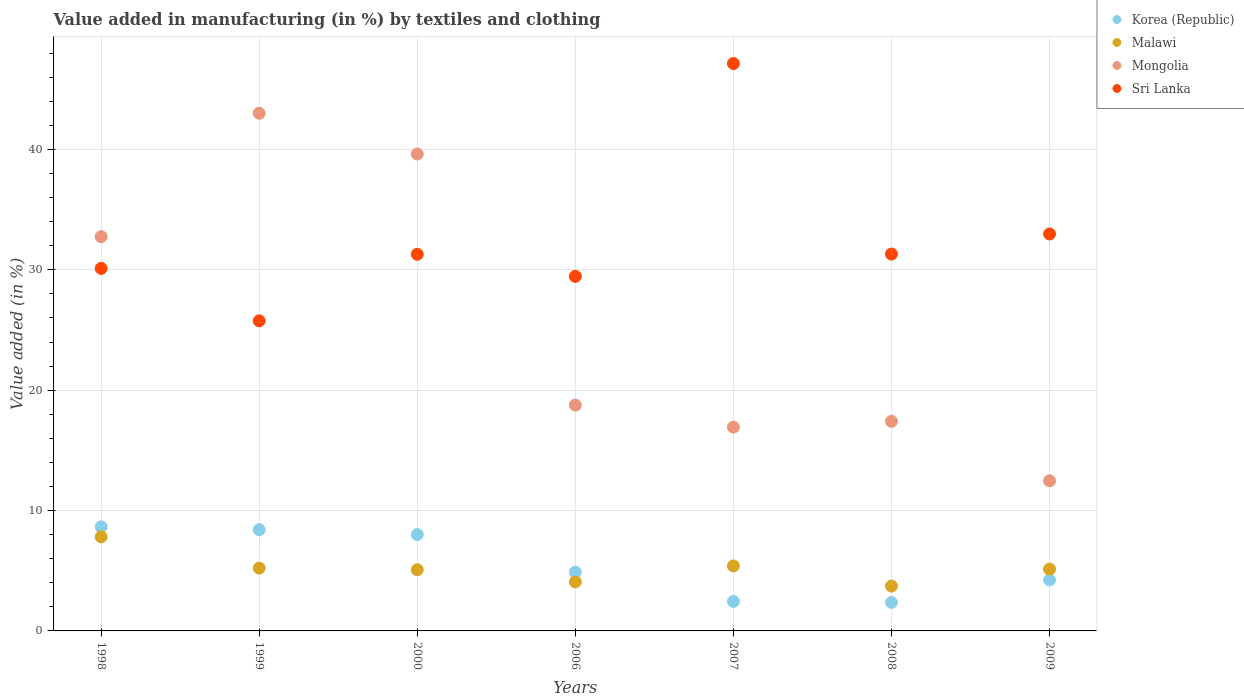Is the number of dotlines equal to the number of legend labels?
Offer a terse response. Yes. What is the percentage of value added in manufacturing by textiles and clothing in Korea (Republic) in 2009?
Ensure brevity in your answer.  4.24. Across all years, what is the maximum percentage of value added in manufacturing by textiles and clothing in Malawi?
Offer a very short reply. 7.82. Across all years, what is the minimum percentage of value added in manufacturing by textiles and clothing in Korea (Republic)?
Offer a terse response. 2.36. What is the total percentage of value added in manufacturing by textiles and clothing in Mongolia in the graph?
Make the answer very short. 180.93. What is the difference between the percentage of value added in manufacturing by textiles and clothing in Korea (Republic) in 1998 and that in 2006?
Provide a succinct answer. 3.76. What is the difference between the percentage of value added in manufacturing by textiles and clothing in Mongolia in 1999 and the percentage of value added in manufacturing by textiles and clothing in Malawi in 2008?
Give a very brief answer. 39.28. What is the average percentage of value added in manufacturing by textiles and clothing in Mongolia per year?
Offer a very short reply. 25.85. In the year 1998, what is the difference between the percentage of value added in manufacturing by textiles and clothing in Korea (Republic) and percentage of value added in manufacturing by textiles and clothing in Mongolia?
Make the answer very short. -24.1. What is the ratio of the percentage of value added in manufacturing by textiles and clothing in Malawi in 2000 to that in 2007?
Provide a short and direct response. 0.94. Is the percentage of value added in manufacturing by textiles and clothing in Korea (Republic) in 1998 less than that in 2008?
Offer a terse response. No. Is the difference between the percentage of value added in manufacturing by textiles and clothing in Korea (Republic) in 1999 and 2009 greater than the difference between the percentage of value added in manufacturing by textiles and clothing in Mongolia in 1999 and 2009?
Keep it short and to the point. No. What is the difference between the highest and the second highest percentage of value added in manufacturing by textiles and clothing in Sri Lanka?
Ensure brevity in your answer.  14.16. What is the difference between the highest and the lowest percentage of value added in manufacturing by textiles and clothing in Mongolia?
Your answer should be very brief. 30.53. Is the percentage of value added in manufacturing by textiles and clothing in Malawi strictly less than the percentage of value added in manufacturing by textiles and clothing in Sri Lanka over the years?
Make the answer very short. Yes. What is the difference between two consecutive major ticks on the Y-axis?
Provide a succinct answer. 10. Does the graph contain any zero values?
Keep it short and to the point. No. Does the graph contain grids?
Provide a short and direct response. Yes. What is the title of the graph?
Give a very brief answer. Value added in manufacturing (in %) by textiles and clothing. Does "Mauritius" appear as one of the legend labels in the graph?
Offer a very short reply. No. What is the label or title of the X-axis?
Ensure brevity in your answer.  Years. What is the label or title of the Y-axis?
Ensure brevity in your answer.  Value added (in %). What is the Value added (in %) in Korea (Republic) in 1998?
Your answer should be compact. 8.65. What is the Value added (in %) of Malawi in 1998?
Make the answer very short. 7.82. What is the Value added (in %) in Mongolia in 1998?
Keep it short and to the point. 32.75. What is the Value added (in %) in Sri Lanka in 1998?
Offer a terse response. 30.11. What is the Value added (in %) of Korea (Republic) in 1999?
Give a very brief answer. 8.41. What is the Value added (in %) of Malawi in 1999?
Offer a very short reply. 5.22. What is the Value added (in %) of Mongolia in 1999?
Make the answer very short. 43.01. What is the Value added (in %) of Sri Lanka in 1999?
Your answer should be compact. 25.76. What is the Value added (in %) in Korea (Republic) in 2000?
Give a very brief answer. 8. What is the Value added (in %) in Malawi in 2000?
Provide a succinct answer. 5.08. What is the Value added (in %) of Mongolia in 2000?
Your answer should be compact. 39.61. What is the Value added (in %) of Sri Lanka in 2000?
Ensure brevity in your answer.  31.29. What is the Value added (in %) of Korea (Republic) in 2006?
Keep it short and to the point. 4.89. What is the Value added (in %) of Malawi in 2006?
Give a very brief answer. 4.07. What is the Value added (in %) in Mongolia in 2006?
Provide a succinct answer. 18.76. What is the Value added (in %) of Sri Lanka in 2006?
Provide a short and direct response. 29.45. What is the Value added (in %) in Korea (Republic) in 2007?
Give a very brief answer. 2.45. What is the Value added (in %) in Malawi in 2007?
Offer a terse response. 5.4. What is the Value added (in %) in Mongolia in 2007?
Your answer should be very brief. 16.93. What is the Value added (in %) of Sri Lanka in 2007?
Provide a short and direct response. 47.13. What is the Value added (in %) in Korea (Republic) in 2008?
Give a very brief answer. 2.36. What is the Value added (in %) of Malawi in 2008?
Provide a succinct answer. 3.73. What is the Value added (in %) in Mongolia in 2008?
Keep it short and to the point. 17.41. What is the Value added (in %) in Sri Lanka in 2008?
Provide a succinct answer. 31.31. What is the Value added (in %) of Korea (Republic) in 2009?
Offer a very short reply. 4.24. What is the Value added (in %) of Malawi in 2009?
Make the answer very short. 5.14. What is the Value added (in %) in Mongolia in 2009?
Make the answer very short. 12.47. What is the Value added (in %) of Sri Lanka in 2009?
Your response must be concise. 32.98. Across all years, what is the maximum Value added (in %) in Korea (Republic)?
Give a very brief answer. 8.65. Across all years, what is the maximum Value added (in %) in Malawi?
Provide a short and direct response. 7.82. Across all years, what is the maximum Value added (in %) of Mongolia?
Offer a terse response. 43.01. Across all years, what is the maximum Value added (in %) of Sri Lanka?
Offer a terse response. 47.13. Across all years, what is the minimum Value added (in %) of Korea (Republic)?
Provide a short and direct response. 2.36. Across all years, what is the minimum Value added (in %) of Malawi?
Your response must be concise. 3.73. Across all years, what is the minimum Value added (in %) of Mongolia?
Provide a short and direct response. 12.47. Across all years, what is the minimum Value added (in %) in Sri Lanka?
Provide a short and direct response. 25.76. What is the total Value added (in %) of Korea (Republic) in the graph?
Provide a succinct answer. 39. What is the total Value added (in %) in Malawi in the graph?
Offer a very short reply. 36.46. What is the total Value added (in %) in Mongolia in the graph?
Keep it short and to the point. 180.93. What is the total Value added (in %) of Sri Lanka in the graph?
Keep it short and to the point. 228.03. What is the difference between the Value added (in %) of Korea (Republic) in 1998 and that in 1999?
Make the answer very short. 0.24. What is the difference between the Value added (in %) in Malawi in 1998 and that in 1999?
Your response must be concise. 2.6. What is the difference between the Value added (in %) of Mongolia in 1998 and that in 1999?
Offer a terse response. -10.26. What is the difference between the Value added (in %) of Sri Lanka in 1998 and that in 1999?
Your answer should be compact. 4.36. What is the difference between the Value added (in %) of Korea (Republic) in 1998 and that in 2000?
Provide a short and direct response. 0.64. What is the difference between the Value added (in %) of Malawi in 1998 and that in 2000?
Your response must be concise. 2.74. What is the difference between the Value added (in %) of Mongolia in 1998 and that in 2000?
Provide a succinct answer. -6.87. What is the difference between the Value added (in %) in Sri Lanka in 1998 and that in 2000?
Give a very brief answer. -1.18. What is the difference between the Value added (in %) in Korea (Republic) in 1998 and that in 2006?
Offer a terse response. 3.76. What is the difference between the Value added (in %) in Malawi in 1998 and that in 2006?
Make the answer very short. 3.74. What is the difference between the Value added (in %) in Mongolia in 1998 and that in 2006?
Offer a very short reply. 13.99. What is the difference between the Value added (in %) in Sri Lanka in 1998 and that in 2006?
Your response must be concise. 0.66. What is the difference between the Value added (in %) in Korea (Republic) in 1998 and that in 2007?
Give a very brief answer. 6.2. What is the difference between the Value added (in %) in Malawi in 1998 and that in 2007?
Offer a very short reply. 2.42. What is the difference between the Value added (in %) of Mongolia in 1998 and that in 2007?
Make the answer very short. 15.82. What is the difference between the Value added (in %) in Sri Lanka in 1998 and that in 2007?
Your answer should be very brief. -17.02. What is the difference between the Value added (in %) in Korea (Republic) in 1998 and that in 2008?
Your answer should be compact. 6.28. What is the difference between the Value added (in %) of Malawi in 1998 and that in 2008?
Keep it short and to the point. 4.09. What is the difference between the Value added (in %) of Mongolia in 1998 and that in 2008?
Provide a short and direct response. 15.34. What is the difference between the Value added (in %) in Sri Lanka in 1998 and that in 2008?
Your response must be concise. -1.19. What is the difference between the Value added (in %) of Korea (Republic) in 1998 and that in 2009?
Provide a short and direct response. 4.41. What is the difference between the Value added (in %) in Malawi in 1998 and that in 2009?
Provide a short and direct response. 2.68. What is the difference between the Value added (in %) in Mongolia in 1998 and that in 2009?
Ensure brevity in your answer.  20.28. What is the difference between the Value added (in %) in Sri Lanka in 1998 and that in 2009?
Your answer should be compact. -2.86. What is the difference between the Value added (in %) of Korea (Republic) in 1999 and that in 2000?
Your answer should be very brief. 0.41. What is the difference between the Value added (in %) in Malawi in 1999 and that in 2000?
Provide a short and direct response. 0.14. What is the difference between the Value added (in %) in Mongolia in 1999 and that in 2000?
Provide a succinct answer. 3.39. What is the difference between the Value added (in %) of Sri Lanka in 1999 and that in 2000?
Offer a terse response. -5.53. What is the difference between the Value added (in %) of Korea (Republic) in 1999 and that in 2006?
Provide a succinct answer. 3.52. What is the difference between the Value added (in %) in Malawi in 1999 and that in 2006?
Your answer should be compact. 1.14. What is the difference between the Value added (in %) of Mongolia in 1999 and that in 2006?
Make the answer very short. 24.25. What is the difference between the Value added (in %) of Sri Lanka in 1999 and that in 2006?
Make the answer very short. -3.7. What is the difference between the Value added (in %) in Korea (Republic) in 1999 and that in 2007?
Ensure brevity in your answer.  5.96. What is the difference between the Value added (in %) in Malawi in 1999 and that in 2007?
Provide a succinct answer. -0.18. What is the difference between the Value added (in %) in Mongolia in 1999 and that in 2007?
Provide a succinct answer. 26.08. What is the difference between the Value added (in %) in Sri Lanka in 1999 and that in 2007?
Make the answer very short. -21.38. What is the difference between the Value added (in %) of Korea (Republic) in 1999 and that in 2008?
Make the answer very short. 6.05. What is the difference between the Value added (in %) in Malawi in 1999 and that in 2008?
Make the answer very short. 1.49. What is the difference between the Value added (in %) of Mongolia in 1999 and that in 2008?
Make the answer very short. 25.6. What is the difference between the Value added (in %) of Sri Lanka in 1999 and that in 2008?
Keep it short and to the point. -5.55. What is the difference between the Value added (in %) of Korea (Republic) in 1999 and that in 2009?
Your answer should be very brief. 4.17. What is the difference between the Value added (in %) of Malawi in 1999 and that in 2009?
Provide a succinct answer. 0.08. What is the difference between the Value added (in %) of Mongolia in 1999 and that in 2009?
Your answer should be compact. 30.53. What is the difference between the Value added (in %) in Sri Lanka in 1999 and that in 2009?
Ensure brevity in your answer.  -7.22. What is the difference between the Value added (in %) in Korea (Republic) in 2000 and that in 2006?
Ensure brevity in your answer.  3.11. What is the difference between the Value added (in %) of Malawi in 2000 and that in 2006?
Your response must be concise. 1.01. What is the difference between the Value added (in %) in Mongolia in 2000 and that in 2006?
Ensure brevity in your answer.  20.86. What is the difference between the Value added (in %) of Sri Lanka in 2000 and that in 2006?
Offer a very short reply. 1.84. What is the difference between the Value added (in %) in Korea (Republic) in 2000 and that in 2007?
Provide a short and direct response. 5.55. What is the difference between the Value added (in %) in Malawi in 2000 and that in 2007?
Give a very brief answer. -0.32. What is the difference between the Value added (in %) of Mongolia in 2000 and that in 2007?
Offer a terse response. 22.69. What is the difference between the Value added (in %) of Sri Lanka in 2000 and that in 2007?
Provide a short and direct response. -15.85. What is the difference between the Value added (in %) of Korea (Republic) in 2000 and that in 2008?
Keep it short and to the point. 5.64. What is the difference between the Value added (in %) in Malawi in 2000 and that in 2008?
Offer a very short reply. 1.35. What is the difference between the Value added (in %) in Mongolia in 2000 and that in 2008?
Your answer should be compact. 22.2. What is the difference between the Value added (in %) in Sri Lanka in 2000 and that in 2008?
Your answer should be very brief. -0.02. What is the difference between the Value added (in %) of Korea (Republic) in 2000 and that in 2009?
Offer a terse response. 3.76. What is the difference between the Value added (in %) of Malawi in 2000 and that in 2009?
Ensure brevity in your answer.  -0.06. What is the difference between the Value added (in %) of Mongolia in 2000 and that in 2009?
Your answer should be compact. 27.14. What is the difference between the Value added (in %) of Sri Lanka in 2000 and that in 2009?
Give a very brief answer. -1.69. What is the difference between the Value added (in %) of Korea (Republic) in 2006 and that in 2007?
Keep it short and to the point. 2.44. What is the difference between the Value added (in %) of Malawi in 2006 and that in 2007?
Your answer should be compact. -1.33. What is the difference between the Value added (in %) of Mongolia in 2006 and that in 2007?
Provide a short and direct response. 1.83. What is the difference between the Value added (in %) of Sri Lanka in 2006 and that in 2007?
Keep it short and to the point. -17.68. What is the difference between the Value added (in %) in Korea (Republic) in 2006 and that in 2008?
Your answer should be very brief. 2.53. What is the difference between the Value added (in %) in Malawi in 2006 and that in 2008?
Ensure brevity in your answer.  0.34. What is the difference between the Value added (in %) in Mongolia in 2006 and that in 2008?
Your response must be concise. 1.35. What is the difference between the Value added (in %) in Sri Lanka in 2006 and that in 2008?
Provide a succinct answer. -1.85. What is the difference between the Value added (in %) of Korea (Republic) in 2006 and that in 2009?
Give a very brief answer. 0.65. What is the difference between the Value added (in %) of Malawi in 2006 and that in 2009?
Your response must be concise. -1.07. What is the difference between the Value added (in %) in Mongolia in 2006 and that in 2009?
Provide a short and direct response. 6.29. What is the difference between the Value added (in %) in Sri Lanka in 2006 and that in 2009?
Provide a short and direct response. -3.52. What is the difference between the Value added (in %) of Korea (Republic) in 2007 and that in 2008?
Ensure brevity in your answer.  0.09. What is the difference between the Value added (in %) in Malawi in 2007 and that in 2008?
Keep it short and to the point. 1.67. What is the difference between the Value added (in %) in Mongolia in 2007 and that in 2008?
Your answer should be compact. -0.48. What is the difference between the Value added (in %) of Sri Lanka in 2007 and that in 2008?
Keep it short and to the point. 15.83. What is the difference between the Value added (in %) in Korea (Republic) in 2007 and that in 2009?
Offer a very short reply. -1.79. What is the difference between the Value added (in %) of Malawi in 2007 and that in 2009?
Your response must be concise. 0.26. What is the difference between the Value added (in %) of Mongolia in 2007 and that in 2009?
Your answer should be very brief. 4.46. What is the difference between the Value added (in %) in Sri Lanka in 2007 and that in 2009?
Give a very brief answer. 14.16. What is the difference between the Value added (in %) of Korea (Republic) in 2008 and that in 2009?
Your answer should be compact. -1.88. What is the difference between the Value added (in %) of Malawi in 2008 and that in 2009?
Your answer should be compact. -1.41. What is the difference between the Value added (in %) of Mongolia in 2008 and that in 2009?
Your answer should be compact. 4.94. What is the difference between the Value added (in %) in Sri Lanka in 2008 and that in 2009?
Provide a succinct answer. -1.67. What is the difference between the Value added (in %) of Korea (Republic) in 1998 and the Value added (in %) of Malawi in 1999?
Your answer should be compact. 3.43. What is the difference between the Value added (in %) of Korea (Republic) in 1998 and the Value added (in %) of Mongolia in 1999?
Your response must be concise. -34.36. What is the difference between the Value added (in %) of Korea (Republic) in 1998 and the Value added (in %) of Sri Lanka in 1999?
Your answer should be very brief. -17.11. What is the difference between the Value added (in %) of Malawi in 1998 and the Value added (in %) of Mongolia in 1999?
Your answer should be very brief. -35.19. What is the difference between the Value added (in %) in Malawi in 1998 and the Value added (in %) in Sri Lanka in 1999?
Make the answer very short. -17.94. What is the difference between the Value added (in %) in Mongolia in 1998 and the Value added (in %) in Sri Lanka in 1999?
Give a very brief answer. 6.99. What is the difference between the Value added (in %) of Korea (Republic) in 1998 and the Value added (in %) of Malawi in 2000?
Offer a terse response. 3.57. What is the difference between the Value added (in %) of Korea (Republic) in 1998 and the Value added (in %) of Mongolia in 2000?
Provide a succinct answer. -30.97. What is the difference between the Value added (in %) in Korea (Republic) in 1998 and the Value added (in %) in Sri Lanka in 2000?
Your answer should be compact. -22.64. What is the difference between the Value added (in %) in Malawi in 1998 and the Value added (in %) in Mongolia in 2000?
Keep it short and to the point. -31.8. What is the difference between the Value added (in %) of Malawi in 1998 and the Value added (in %) of Sri Lanka in 2000?
Make the answer very short. -23.47. What is the difference between the Value added (in %) of Mongolia in 1998 and the Value added (in %) of Sri Lanka in 2000?
Your response must be concise. 1.46. What is the difference between the Value added (in %) in Korea (Republic) in 1998 and the Value added (in %) in Malawi in 2006?
Provide a succinct answer. 4.57. What is the difference between the Value added (in %) in Korea (Republic) in 1998 and the Value added (in %) in Mongolia in 2006?
Your answer should be very brief. -10.11. What is the difference between the Value added (in %) of Korea (Republic) in 1998 and the Value added (in %) of Sri Lanka in 2006?
Your response must be concise. -20.81. What is the difference between the Value added (in %) in Malawi in 1998 and the Value added (in %) in Mongolia in 2006?
Offer a very short reply. -10.94. What is the difference between the Value added (in %) of Malawi in 1998 and the Value added (in %) of Sri Lanka in 2006?
Your response must be concise. -21.64. What is the difference between the Value added (in %) of Mongolia in 1998 and the Value added (in %) of Sri Lanka in 2006?
Provide a succinct answer. 3.29. What is the difference between the Value added (in %) of Korea (Republic) in 1998 and the Value added (in %) of Malawi in 2007?
Offer a very short reply. 3.25. What is the difference between the Value added (in %) of Korea (Republic) in 1998 and the Value added (in %) of Mongolia in 2007?
Your answer should be very brief. -8.28. What is the difference between the Value added (in %) in Korea (Republic) in 1998 and the Value added (in %) in Sri Lanka in 2007?
Provide a succinct answer. -38.49. What is the difference between the Value added (in %) in Malawi in 1998 and the Value added (in %) in Mongolia in 2007?
Provide a short and direct response. -9.11. What is the difference between the Value added (in %) of Malawi in 1998 and the Value added (in %) of Sri Lanka in 2007?
Provide a succinct answer. -39.32. What is the difference between the Value added (in %) in Mongolia in 1998 and the Value added (in %) in Sri Lanka in 2007?
Provide a succinct answer. -14.39. What is the difference between the Value added (in %) of Korea (Republic) in 1998 and the Value added (in %) of Malawi in 2008?
Provide a short and direct response. 4.92. What is the difference between the Value added (in %) of Korea (Republic) in 1998 and the Value added (in %) of Mongolia in 2008?
Give a very brief answer. -8.76. What is the difference between the Value added (in %) in Korea (Republic) in 1998 and the Value added (in %) in Sri Lanka in 2008?
Your answer should be compact. -22.66. What is the difference between the Value added (in %) of Malawi in 1998 and the Value added (in %) of Mongolia in 2008?
Offer a terse response. -9.59. What is the difference between the Value added (in %) of Malawi in 1998 and the Value added (in %) of Sri Lanka in 2008?
Offer a terse response. -23.49. What is the difference between the Value added (in %) in Mongolia in 1998 and the Value added (in %) in Sri Lanka in 2008?
Offer a terse response. 1.44. What is the difference between the Value added (in %) of Korea (Republic) in 1998 and the Value added (in %) of Malawi in 2009?
Provide a short and direct response. 3.51. What is the difference between the Value added (in %) in Korea (Republic) in 1998 and the Value added (in %) in Mongolia in 2009?
Provide a short and direct response. -3.82. What is the difference between the Value added (in %) in Korea (Republic) in 1998 and the Value added (in %) in Sri Lanka in 2009?
Give a very brief answer. -24.33. What is the difference between the Value added (in %) in Malawi in 1998 and the Value added (in %) in Mongolia in 2009?
Provide a succinct answer. -4.65. What is the difference between the Value added (in %) in Malawi in 1998 and the Value added (in %) in Sri Lanka in 2009?
Provide a succinct answer. -25.16. What is the difference between the Value added (in %) in Mongolia in 1998 and the Value added (in %) in Sri Lanka in 2009?
Your answer should be compact. -0.23. What is the difference between the Value added (in %) of Korea (Republic) in 1999 and the Value added (in %) of Malawi in 2000?
Make the answer very short. 3.33. What is the difference between the Value added (in %) in Korea (Republic) in 1999 and the Value added (in %) in Mongolia in 2000?
Ensure brevity in your answer.  -31.2. What is the difference between the Value added (in %) of Korea (Republic) in 1999 and the Value added (in %) of Sri Lanka in 2000?
Offer a terse response. -22.88. What is the difference between the Value added (in %) in Malawi in 1999 and the Value added (in %) in Mongolia in 2000?
Ensure brevity in your answer.  -34.4. What is the difference between the Value added (in %) in Malawi in 1999 and the Value added (in %) in Sri Lanka in 2000?
Your response must be concise. -26.07. What is the difference between the Value added (in %) in Mongolia in 1999 and the Value added (in %) in Sri Lanka in 2000?
Keep it short and to the point. 11.72. What is the difference between the Value added (in %) in Korea (Republic) in 1999 and the Value added (in %) in Malawi in 2006?
Keep it short and to the point. 4.34. What is the difference between the Value added (in %) in Korea (Republic) in 1999 and the Value added (in %) in Mongolia in 2006?
Your answer should be very brief. -10.35. What is the difference between the Value added (in %) in Korea (Republic) in 1999 and the Value added (in %) in Sri Lanka in 2006?
Provide a short and direct response. -21.04. What is the difference between the Value added (in %) in Malawi in 1999 and the Value added (in %) in Mongolia in 2006?
Keep it short and to the point. -13.54. What is the difference between the Value added (in %) in Malawi in 1999 and the Value added (in %) in Sri Lanka in 2006?
Offer a terse response. -24.24. What is the difference between the Value added (in %) of Mongolia in 1999 and the Value added (in %) of Sri Lanka in 2006?
Make the answer very short. 13.55. What is the difference between the Value added (in %) of Korea (Republic) in 1999 and the Value added (in %) of Malawi in 2007?
Offer a terse response. 3.01. What is the difference between the Value added (in %) in Korea (Republic) in 1999 and the Value added (in %) in Mongolia in 2007?
Offer a terse response. -8.52. What is the difference between the Value added (in %) of Korea (Republic) in 1999 and the Value added (in %) of Sri Lanka in 2007?
Give a very brief answer. -38.73. What is the difference between the Value added (in %) of Malawi in 1999 and the Value added (in %) of Mongolia in 2007?
Provide a succinct answer. -11.71. What is the difference between the Value added (in %) of Malawi in 1999 and the Value added (in %) of Sri Lanka in 2007?
Offer a terse response. -41.92. What is the difference between the Value added (in %) of Mongolia in 1999 and the Value added (in %) of Sri Lanka in 2007?
Provide a short and direct response. -4.13. What is the difference between the Value added (in %) in Korea (Republic) in 1999 and the Value added (in %) in Malawi in 2008?
Offer a terse response. 4.68. What is the difference between the Value added (in %) in Korea (Republic) in 1999 and the Value added (in %) in Mongolia in 2008?
Provide a succinct answer. -9. What is the difference between the Value added (in %) of Korea (Republic) in 1999 and the Value added (in %) of Sri Lanka in 2008?
Provide a short and direct response. -22.9. What is the difference between the Value added (in %) in Malawi in 1999 and the Value added (in %) in Mongolia in 2008?
Make the answer very short. -12.19. What is the difference between the Value added (in %) in Malawi in 1999 and the Value added (in %) in Sri Lanka in 2008?
Your response must be concise. -26.09. What is the difference between the Value added (in %) of Mongolia in 1999 and the Value added (in %) of Sri Lanka in 2008?
Make the answer very short. 11.7. What is the difference between the Value added (in %) of Korea (Republic) in 1999 and the Value added (in %) of Malawi in 2009?
Keep it short and to the point. 3.27. What is the difference between the Value added (in %) of Korea (Republic) in 1999 and the Value added (in %) of Mongolia in 2009?
Your answer should be compact. -4.06. What is the difference between the Value added (in %) in Korea (Republic) in 1999 and the Value added (in %) in Sri Lanka in 2009?
Ensure brevity in your answer.  -24.57. What is the difference between the Value added (in %) in Malawi in 1999 and the Value added (in %) in Mongolia in 2009?
Keep it short and to the point. -7.25. What is the difference between the Value added (in %) of Malawi in 1999 and the Value added (in %) of Sri Lanka in 2009?
Provide a succinct answer. -27.76. What is the difference between the Value added (in %) in Mongolia in 1999 and the Value added (in %) in Sri Lanka in 2009?
Make the answer very short. 10.03. What is the difference between the Value added (in %) in Korea (Republic) in 2000 and the Value added (in %) in Malawi in 2006?
Keep it short and to the point. 3.93. What is the difference between the Value added (in %) of Korea (Republic) in 2000 and the Value added (in %) of Mongolia in 2006?
Provide a succinct answer. -10.75. What is the difference between the Value added (in %) of Korea (Republic) in 2000 and the Value added (in %) of Sri Lanka in 2006?
Offer a very short reply. -21.45. What is the difference between the Value added (in %) of Malawi in 2000 and the Value added (in %) of Mongolia in 2006?
Give a very brief answer. -13.67. What is the difference between the Value added (in %) of Malawi in 2000 and the Value added (in %) of Sri Lanka in 2006?
Ensure brevity in your answer.  -24.37. What is the difference between the Value added (in %) of Mongolia in 2000 and the Value added (in %) of Sri Lanka in 2006?
Your answer should be very brief. 10.16. What is the difference between the Value added (in %) of Korea (Republic) in 2000 and the Value added (in %) of Malawi in 2007?
Give a very brief answer. 2.6. What is the difference between the Value added (in %) in Korea (Republic) in 2000 and the Value added (in %) in Mongolia in 2007?
Make the answer very short. -8.92. What is the difference between the Value added (in %) of Korea (Republic) in 2000 and the Value added (in %) of Sri Lanka in 2007?
Ensure brevity in your answer.  -39.13. What is the difference between the Value added (in %) of Malawi in 2000 and the Value added (in %) of Mongolia in 2007?
Your answer should be compact. -11.85. What is the difference between the Value added (in %) in Malawi in 2000 and the Value added (in %) in Sri Lanka in 2007?
Provide a short and direct response. -42.05. What is the difference between the Value added (in %) in Mongolia in 2000 and the Value added (in %) in Sri Lanka in 2007?
Make the answer very short. -7.52. What is the difference between the Value added (in %) of Korea (Republic) in 2000 and the Value added (in %) of Malawi in 2008?
Your answer should be very brief. 4.27. What is the difference between the Value added (in %) of Korea (Republic) in 2000 and the Value added (in %) of Mongolia in 2008?
Ensure brevity in your answer.  -9.41. What is the difference between the Value added (in %) of Korea (Republic) in 2000 and the Value added (in %) of Sri Lanka in 2008?
Your answer should be very brief. -23.3. What is the difference between the Value added (in %) of Malawi in 2000 and the Value added (in %) of Mongolia in 2008?
Your answer should be compact. -12.33. What is the difference between the Value added (in %) of Malawi in 2000 and the Value added (in %) of Sri Lanka in 2008?
Provide a short and direct response. -26.23. What is the difference between the Value added (in %) in Mongolia in 2000 and the Value added (in %) in Sri Lanka in 2008?
Make the answer very short. 8.31. What is the difference between the Value added (in %) in Korea (Republic) in 2000 and the Value added (in %) in Malawi in 2009?
Keep it short and to the point. 2.86. What is the difference between the Value added (in %) in Korea (Republic) in 2000 and the Value added (in %) in Mongolia in 2009?
Make the answer very short. -4.47. What is the difference between the Value added (in %) of Korea (Republic) in 2000 and the Value added (in %) of Sri Lanka in 2009?
Give a very brief answer. -24.97. What is the difference between the Value added (in %) of Malawi in 2000 and the Value added (in %) of Mongolia in 2009?
Your answer should be very brief. -7.39. What is the difference between the Value added (in %) of Malawi in 2000 and the Value added (in %) of Sri Lanka in 2009?
Make the answer very short. -27.89. What is the difference between the Value added (in %) of Mongolia in 2000 and the Value added (in %) of Sri Lanka in 2009?
Keep it short and to the point. 6.64. What is the difference between the Value added (in %) of Korea (Republic) in 2006 and the Value added (in %) of Malawi in 2007?
Provide a succinct answer. -0.51. What is the difference between the Value added (in %) of Korea (Republic) in 2006 and the Value added (in %) of Mongolia in 2007?
Provide a short and direct response. -12.04. What is the difference between the Value added (in %) of Korea (Republic) in 2006 and the Value added (in %) of Sri Lanka in 2007?
Ensure brevity in your answer.  -42.25. What is the difference between the Value added (in %) of Malawi in 2006 and the Value added (in %) of Mongolia in 2007?
Keep it short and to the point. -12.85. What is the difference between the Value added (in %) in Malawi in 2006 and the Value added (in %) in Sri Lanka in 2007?
Give a very brief answer. -43.06. What is the difference between the Value added (in %) in Mongolia in 2006 and the Value added (in %) in Sri Lanka in 2007?
Provide a succinct answer. -28.38. What is the difference between the Value added (in %) of Korea (Republic) in 2006 and the Value added (in %) of Malawi in 2008?
Your answer should be very brief. 1.16. What is the difference between the Value added (in %) in Korea (Republic) in 2006 and the Value added (in %) in Mongolia in 2008?
Keep it short and to the point. -12.52. What is the difference between the Value added (in %) in Korea (Republic) in 2006 and the Value added (in %) in Sri Lanka in 2008?
Provide a succinct answer. -26.42. What is the difference between the Value added (in %) in Malawi in 2006 and the Value added (in %) in Mongolia in 2008?
Offer a terse response. -13.34. What is the difference between the Value added (in %) in Malawi in 2006 and the Value added (in %) in Sri Lanka in 2008?
Your response must be concise. -27.23. What is the difference between the Value added (in %) of Mongolia in 2006 and the Value added (in %) of Sri Lanka in 2008?
Your response must be concise. -12.55. What is the difference between the Value added (in %) in Korea (Republic) in 2006 and the Value added (in %) in Malawi in 2009?
Keep it short and to the point. -0.25. What is the difference between the Value added (in %) in Korea (Republic) in 2006 and the Value added (in %) in Mongolia in 2009?
Provide a succinct answer. -7.58. What is the difference between the Value added (in %) in Korea (Republic) in 2006 and the Value added (in %) in Sri Lanka in 2009?
Ensure brevity in your answer.  -28.09. What is the difference between the Value added (in %) of Malawi in 2006 and the Value added (in %) of Mongolia in 2009?
Ensure brevity in your answer.  -8.4. What is the difference between the Value added (in %) in Malawi in 2006 and the Value added (in %) in Sri Lanka in 2009?
Ensure brevity in your answer.  -28.9. What is the difference between the Value added (in %) in Mongolia in 2006 and the Value added (in %) in Sri Lanka in 2009?
Give a very brief answer. -14.22. What is the difference between the Value added (in %) in Korea (Republic) in 2007 and the Value added (in %) in Malawi in 2008?
Provide a short and direct response. -1.28. What is the difference between the Value added (in %) of Korea (Republic) in 2007 and the Value added (in %) of Mongolia in 2008?
Your answer should be compact. -14.96. What is the difference between the Value added (in %) in Korea (Republic) in 2007 and the Value added (in %) in Sri Lanka in 2008?
Provide a succinct answer. -28.86. What is the difference between the Value added (in %) of Malawi in 2007 and the Value added (in %) of Mongolia in 2008?
Your response must be concise. -12.01. What is the difference between the Value added (in %) of Malawi in 2007 and the Value added (in %) of Sri Lanka in 2008?
Give a very brief answer. -25.91. What is the difference between the Value added (in %) in Mongolia in 2007 and the Value added (in %) in Sri Lanka in 2008?
Your answer should be very brief. -14.38. What is the difference between the Value added (in %) in Korea (Republic) in 2007 and the Value added (in %) in Malawi in 2009?
Give a very brief answer. -2.69. What is the difference between the Value added (in %) in Korea (Republic) in 2007 and the Value added (in %) in Mongolia in 2009?
Provide a succinct answer. -10.02. What is the difference between the Value added (in %) in Korea (Republic) in 2007 and the Value added (in %) in Sri Lanka in 2009?
Your answer should be compact. -30.53. What is the difference between the Value added (in %) in Malawi in 2007 and the Value added (in %) in Mongolia in 2009?
Offer a very short reply. -7.07. What is the difference between the Value added (in %) of Malawi in 2007 and the Value added (in %) of Sri Lanka in 2009?
Your answer should be very brief. -27.58. What is the difference between the Value added (in %) in Mongolia in 2007 and the Value added (in %) in Sri Lanka in 2009?
Give a very brief answer. -16.05. What is the difference between the Value added (in %) in Korea (Republic) in 2008 and the Value added (in %) in Malawi in 2009?
Offer a very short reply. -2.78. What is the difference between the Value added (in %) of Korea (Republic) in 2008 and the Value added (in %) of Mongolia in 2009?
Give a very brief answer. -10.11. What is the difference between the Value added (in %) of Korea (Republic) in 2008 and the Value added (in %) of Sri Lanka in 2009?
Your response must be concise. -30.61. What is the difference between the Value added (in %) of Malawi in 2008 and the Value added (in %) of Mongolia in 2009?
Your answer should be compact. -8.74. What is the difference between the Value added (in %) of Malawi in 2008 and the Value added (in %) of Sri Lanka in 2009?
Provide a succinct answer. -29.25. What is the difference between the Value added (in %) of Mongolia in 2008 and the Value added (in %) of Sri Lanka in 2009?
Your answer should be very brief. -15.57. What is the average Value added (in %) of Korea (Republic) per year?
Your answer should be very brief. 5.57. What is the average Value added (in %) in Malawi per year?
Make the answer very short. 5.21. What is the average Value added (in %) of Mongolia per year?
Provide a short and direct response. 25.85. What is the average Value added (in %) in Sri Lanka per year?
Offer a very short reply. 32.58. In the year 1998, what is the difference between the Value added (in %) in Korea (Republic) and Value added (in %) in Malawi?
Offer a very short reply. 0.83. In the year 1998, what is the difference between the Value added (in %) in Korea (Republic) and Value added (in %) in Mongolia?
Your response must be concise. -24.1. In the year 1998, what is the difference between the Value added (in %) of Korea (Republic) and Value added (in %) of Sri Lanka?
Keep it short and to the point. -21.47. In the year 1998, what is the difference between the Value added (in %) of Malawi and Value added (in %) of Mongolia?
Provide a succinct answer. -24.93. In the year 1998, what is the difference between the Value added (in %) in Malawi and Value added (in %) in Sri Lanka?
Keep it short and to the point. -22.3. In the year 1998, what is the difference between the Value added (in %) of Mongolia and Value added (in %) of Sri Lanka?
Offer a terse response. 2.63. In the year 1999, what is the difference between the Value added (in %) of Korea (Republic) and Value added (in %) of Malawi?
Keep it short and to the point. 3.19. In the year 1999, what is the difference between the Value added (in %) in Korea (Republic) and Value added (in %) in Mongolia?
Ensure brevity in your answer.  -34.6. In the year 1999, what is the difference between the Value added (in %) in Korea (Republic) and Value added (in %) in Sri Lanka?
Provide a short and direct response. -17.35. In the year 1999, what is the difference between the Value added (in %) of Malawi and Value added (in %) of Mongolia?
Your answer should be compact. -37.79. In the year 1999, what is the difference between the Value added (in %) of Malawi and Value added (in %) of Sri Lanka?
Your answer should be very brief. -20.54. In the year 1999, what is the difference between the Value added (in %) in Mongolia and Value added (in %) in Sri Lanka?
Keep it short and to the point. 17.25. In the year 2000, what is the difference between the Value added (in %) of Korea (Republic) and Value added (in %) of Malawi?
Provide a succinct answer. 2.92. In the year 2000, what is the difference between the Value added (in %) of Korea (Republic) and Value added (in %) of Mongolia?
Make the answer very short. -31.61. In the year 2000, what is the difference between the Value added (in %) in Korea (Republic) and Value added (in %) in Sri Lanka?
Your answer should be very brief. -23.29. In the year 2000, what is the difference between the Value added (in %) of Malawi and Value added (in %) of Mongolia?
Your answer should be compact. -34.53. In the year 2000, what is the difference between the Value added (in %) of Malawi and Value added (in %) of Sri Lanka?
Offer a terse response. -26.21. In the year 2000, what is the difference between the Value added (in %) of Mongolia and Value added (in %) of Sri Lanka?
Give a very brief answer. 8.32. In the year 2006, what is the difference between the Value added (in %) of Korea (Republic) and Value added (in %) of Malawi?
Your response must be concise. 0.82. In the year 2006, what is the difference between the Value added (in %) in Korea (Republic) and Value added (in %) in Mongolia?
Make the answer very short. -13.87. In the year 2006, what is the difference between the Value added (in %) in Korea (Republic) and Value added (in %) in Sri Lanka?
Your answer should be very brief. -24.56. In the year 2006, what is the difference between the Value added (in %) in Malawi and Value added (in %) in Mongolia?
Make the answer very short. -14.68. In the year 2006, what is the difference between the Value added (in %) of Malawi and Value added (in %) of Sri Lanka?
Give a very brief answer. -25.38. In the year 2006, what is the difference between the Value added (in %) in Mongolia and Value added (in %) in Sri Lanka?
Offer a terse response. -10.7. In the year 2007, what is the difference between the Value added (in %) in Korea (Republic) and Value added (in %) in Malawi?
Your response must be concise. -2.95. In the year 2007, what is the difference between the Value added (in %) in Korea (Republic) and Value added (in %) in Mongolia?
Offer a terse response. -14.48. In the year 2007, what is the difference between the Value added (in %) in Korea (Republic) and Value added (in %) in Sri Lanka?
Your answer should be compact. -44.69. In the year 2007, what is the difference between the Value added (in %) of Malawi and Value added (in %) of Mongolia?
Give a very brief answer. -11.53. In the year 2007, what is the difference between the Value added (in %) in Malawi and Value added (in %) in Sri Lanka?
Provide a short and direct response. -41.73. In the year 2007, what is the difference between the Value added (in %) in Mongolia and Value added (in %) in Sri Lanka?
Give a very brief answer. -30.21. In the year 2008, what is the difference between the Value added (in %) in Korea (Republic) and Value added (in %) in Malawi?
Provide a short and direct response. -1.37. In the year 2008, what is the difference between the Value added (in %) in Korea (Republic) and Value added (in %) in Mongolia?
Your answer should be very brief. -15.05. In the year 2008, what is the difference between the Value added (in %) in Korea (Republic) and Value added (in %) in Sri Lanka?
Your answer should be very brief. -28.94. In the year 2008, what is the difference between the Value added (in %) of Malawi and Value added (in %) of Mongolia?
Your response must be concise. -13.68. In the year 2008, what is the difference between the Value added (in %) of Malawi and Value added (in %) of Sri Lanka?
Provide a short and direct response. -27.58. In the year 2008, what is the difference between the Value added (in %) in Mongolia and Value added (in %) in Sri Lanka?
Provide a succinct answer. -13.9. In the year 2009, what is the difference between the Value added (in %) in Korea (Republic) and Value added (in %) in Malawi?
Your response must be concise. -0.9. In the year 2009, what is the difference between the Value added (in %) of Korea (Republic) and Value added (in %) of Mongolia?
Offer a very short reply. -8.23. In the year 2009, what is the difference between the Value added (in %) in Korea (Republic) and Value added (in %) in Sri Lanka?
Keep it short and to the point. -28.74. In the year 2009, what is the difference between the Value added (in %) in Malawi and Value added (in %) in Mongolia?
Provide a succinct answer. -7.33. In the year 2009, what is the difference between the Value added (in %) in Malawi and Value added (in %) in Sri Lanka?
Offer a very short reply. -27.84. In the year 2009, what is the difference between the Value added (in %) of Mongolia and Value added (in %) of Sri Lanka?
Offer a terse response. -20.5. What is the ratio of the Value added (in %) of Korea (Republic) in 1998 to that in 1999?
Make the answer very short. 1.03. What is the ratio of the Value added (in %) in Malawi in 1998 to that in 1999?
Your answer should be very brief. 1.5. What is the ratio of the Value added (in %) of Mongolia in 1998 to that in 1999?
Provide a short and direct response. 0.76. What is the ratio of the Value added (in %) in Sri Lanka in 1998 to that in 1999?
Provide a short and direct response. 1.17. What is the ratio of the Value added (in %) in Korea (Republic) in 1998 to that in 2000?
Ensure brevity in your answer.  1.08. What is the ratio of the Value added (in %) of Malawi in 1998 to that in 2000?
Give a very brief answer. 1.54. What is the ratio of the Value added (in %) of Mongolia in 1998 to that in 2000?
Ensure brevity in your answer.  0.83. What is the ratio of the Value added (in %) in Sri Lanka in 1998 to that in 2000?
Ensure brevity in your answer.  0.96. What is the ratio of the Value added (in %) in Korea (Republic) in 1998 to that in 2006?
Give a very brief answer. 1.77. What is the ratio of the Value added (in %) in Malawi in 1998 to that in 2006?
Provide a short and direct response. 1.92. What is the ratio of the Value added (in %) in Mongolia in 1998 to that in 2006?
Offer a terse response. 1.75. What is the ratio of the Value added (in %) in Sri Lanka in 1998 to that in 2006?
Your response must be concise. 1.02. What is the ratio of the Value added (in %) in Korea (Republic) in 1998 to that in 2007?
Keep it short and to the point. 3.53. What is the ratio of the Value added (in %) in Malawi in 1998 to that in 2007?
Provide a short and direct response. 1.45. What is the ratio of the Value added (in %) of Mongolia in 1998 to that in 2007?
Keep it short and to the point. 1.93. What is the ratio of the Value added (in %) in Sri Lanka in 1998 to that in 2007?
Make the answer very short. 0.64. What is the ratio of the Value added (in %) in Korea (Republic) in 1998 to that in 2008?
Your response must be concise. 3.66. What is the ratio of the Value added (in %) of Malawi in 1998 to that in 2008?
Keep it short and to the point. 2.1. What is the ratio of the Value added (in %) in Mongolia in 1998 to that in 2008?
Offer a very short reply. 1.88. What is the ratio of the Value added (in %) of Sri Lanka in 1998 to that in 2008?
Provide a succinct answer. 0.96. What is the ratio of the Value added (in %) of Korea (Republic) in 1998 to that in 2009?
Give a very brief answer. 2.04. What is the ratio of the Value added (in %) in Malawi in 1998 to that in 2009?
Offer a terse response. 1.52. What is the ratio of the Value added (in %) in Mongolia in 1998 to that in 2009?
Provide a short and direct response. 2.63. What is the ratio of the Value added (in %) in Sri Lanka in 1998 to that in 2009?
Your answer should be very brief. 0.91. What is the ratio of the Value added (in %) of Korea (Republic) in 1999 to that in 2000?
Keep it short and to the point. 1.05. What is the ratio of the Value added (in %) of Malawi in 1999 to that in 2000?
Your answer should be compact. 1.03. What is the ratio of the Value added (in %) of Mongolia in 1999 to that in 2000?
Ensure brevity in your answer.  1.09. What is the ratio of the Value added (in %) of Sri Lanka in 1999 to that in 2000?
Make the answer very short. 0.82. What is the ratio of the Value added (in %) in Korea (Republic) in 1999 to that in 2006?
Make the answer very short. 1.72. What is the ratio of the Value added (in %) in Malawi in 1999 to that in 2006?
Provide a short and direct response. 1.28. What is the ratio of the Value added (in %) in Mongolia in 1999 to that in 2006?
Make the answer very short. 2.29. What is the ratio of the Value added (in %) of Sri Lanka in 1999 to that in 2006?
Ensure brevity in your answer.  0.87. What is the ratio of the Value added (in %) in Korea (Republic) in 1999 to that in 2007?
Offer a very short reply. 3.43. What is the ratio of the Value added (in %) of Malawi in 1999 to that in 2007?
Ensure brevity in your answer.  0.97. What is the ratio of the Value added (in %) in Mongolia in 1999 to that in 2007?
Provide a short and direct response. 2.54. What is the ratio of the Value added (in %) of Sri Lanka in 1999 to that in 2007?
Your answer should be compact. 0.55. What is the ratio of the Value added (in %) in Korea (Republic) in 1999 to that in 2008?
Give a very brief answer. 3.56. What is the ratio of the Value added (in %) in Malawi in 1999 to that in 2008?
Provide a short and direct response. 1.4. What is the ratio of the Value added (in %) of Mongolia in 1999 to that in 2008?
Your answer should be compact. 2.47. What is the ratio of the Value added (in %) in Sri Lanka in 1999 to that in 2008?
Give a very brief answer. 0.82. What is the ratio of the Value added (in %) of Korea (Republic) in 1999 to that in 2009?
Make the answer very short. 1.98. What is the ratio of the Value added (in %) in Malawi in 1999 to that in 2009?
Offer a terse response. 1.02. What is the ratio of the Value added (in %) of Mongolia in 1999 to that in 2009?
Your answer should be very brief. 3.45. What is the ratio of the Value added (in %) of Sri Lanka in 1999 to that in 2009?
Make the answer very short. 0.78. What is the ratio of the Value added (in %) in Korea (Republic) in 2000 to that in 2006?
Your answer should be very brief. 1.64. What is the ratio of the Value added (in %) of Malawi in 2000 to that in 2006?
Offer a very short reply. 1.25. What is the ratio of the Value added (in %) in Mongolia in 2000 to that in 2006?
Keep it short and to the point. 2.11. What is the ratio of the Value added (in %) in Sri Lanka in 2000 to that in 2006?
Offer a very short reply. 1.06. What is the ratio of the Value added (in %) of Korea (Republic) in 2000 to that in 2007?
Give a very brief answer. 3.27. What is the ratio of the Value added (in %) in Malawi in 2000 to that in 2007?
Keep it short and to the point. 0.94. What is the ratio of the Value added (in %) of Mongolia in 2000 to that in 2007?
Offer a terse response. 2.34. What is the ratio of the Value added (in %) in Sri Lanka in 2000 to that in 2007?
Make the answer very short. 0.66. What is the ratio of the Value added (in %) in Korea (Republic) in 2000 to that in 2008?
Your response must be concise. 3.39. What is the ratio of the Value added (in %) of Malawi in 2000 to that in 2008?
Your response must be concise. 1.36. What is the ratio of the Value added (in %) in Mongolia in 2000 to that in 2008?
Keep it short and to the point. 2.28. What is the ratio of the Value added (in %) in Sri Lanka in 2000 to that in 2008?
Offer a terse response. 1. What is the ratio of the Value added (in %) of Korea (Republic) in 2000 to that in 2009?
Keep it short and to the point. 1.89. What is the ratio of the Value added (in %) of Malawi in 2000 to that in 2009?
Your answer should be compact. 0.99. What is the ratio of the Value added (in %) in Mongolia in 2000 to that in 2009?
Your answer should be compact. 3.18. What is the ratio of the Value added (in %) in Sri Lanka in 2000 to that in 2009?
Keep it short and to the point. 0.95. What is the ratio of the Value added (in %) in Korea (Republic) in 2006 to that in 2007?
Give a very brief answer. 2. What is the ratio of the Value added (in %) in Malawi in 2006 to that in 2007?
Provide a succinct answer. 0.75. What is the ratio of the Value added (in %) in Mongolia in 2006 to that in 2007?
Offer a very short reply. 1.11. What is the ratio of the Value added (in %) in Sri Lanka in 2006 to that in 2007?
Offer a terse response. 0.62. What is the ratio of the Value added (in %) in Korea (Republic) in 2006 to that in 2008?
Your answer should be very brief. 2.07. What is the ratio of the Value added (in %) in Malawi in 2006 to that in 2008?
Make the answer very short. 1.09. What is the ratio of the Value added (in %) in Mongolia in 2006 to that in 2008?
Give a very brief answer. 1.08. What is the ratio of the Value added (in %) in Sri Lanka in 2006 to that in 2008?
Offer a very short reply. 0.94. What is the ratio of the Value added (in %) of Korea (Republic) in 2006 to that in 2009?
Provide a short and direct response. 1.15. What is the ratio of the Value added (in %) in Malawi in 2006 to that in 2009?
Make the answer very short. 0.79. What is the ratio of the Value added (in %) in Mongolia in 2006 to that in 2009?
Your response must be concise. 1.5. What is the ratio of the Value added (in %) in Sri Lanka in 2006 to that in 2009?
Your response must be concise. 0.89. What is the ratio of the Value added (in %) of Korea (Republic) in 2007 to that in 2008?
Offer a very short reply. 1.04. What is the ratio of the Value added (in %) in Malawi in 2007 to that in 2008?
Your response must be concise. 1.45. What is the ratio of the Value added (in %) of Mongolia in 2007 to that in 2008?
Your answer should be compact. 0.97. What is the ratio of the Value added (in %) of Sri Lanka in 2007 to that in 2008?
Give a very brief answer. 1.51. What is the ratio of the Value added (in %) of Korea (Republic) in 2007 to that in 2009?
Give a very brief answer. 0.58. What is the ratio of the Value added (in %) in Malawi in 2007 to that in 2009?
Your answer should be very brief. 1.05. What is the ratio of the Value added (in %) of Mongolia in 2007 to that in 2009?
Give a very brief answer. 1.36. What is the ratio of the Value added (in %) in Sri Lanka in 2007 to that in 2009?
Offer a terse response. 1.43. What is the ratio of the Value added (in %) in Korea (Republic) in 2008 to that in 2009?
Your answer should be very brief. 0.56. What is the ratio of the Value added (in %) of Malawi in 2008 to that in 2009?
Provide a succinct answer. 0.73. What is the ratio of the Value added (in %) of Mongolia in 2008 to that in 2009?
Make the answer very short. 1.4. What is the ratio of the Value added (in %) in Sri Lanka in 2008 to that in 2009?
Offer a terse response. 0.95. What is the difference between the highest and the second highest Value added (in %) in Korea (Republic)?
Your answer should be very brief. 0.24. What is the difference between the highest and the second highest Value added (in %) in Malawi?
Provide a short and direct response. 2.42. What is the difference between the highest and the second highest Value added (in %) of Mongolia?
Provide a short and direct response. 3.39. What is the difference between the highest and the second highest Value added (in %) of Sri Lanka?
Make the answer very short. 14.16. What is the difference between the highest and the lowest Value added (in %) of Korea (Republic)?
Make the answer very short. 6.28. What is the difference between the highest and the lowest Value added (in %) of Malawi?
Your response must be concise. 4.09. What is the difference between the highest and the lowest Value added (in %) of Mongolia?
Keep it short and to the point. 30.53. What is the difference between the highest and the lowest Value added (in %) of Sri Lanka?
Ensure brevity in your answer.  21.38. 